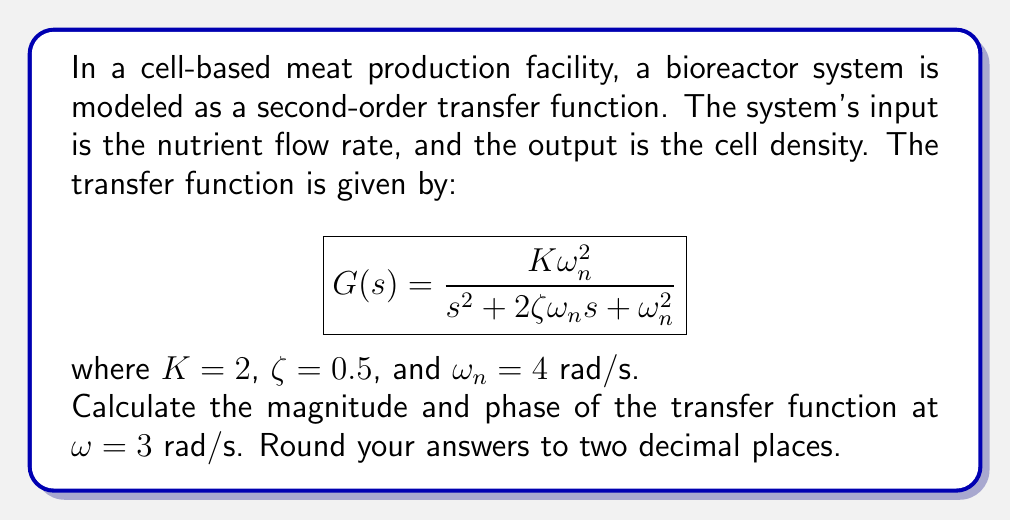Teach me how to tackle this problem. To solve this problem, we'll follow these steps:

1) First, we substitute $s = j\omega$ into the transfer function:

   $$G(j\omega) = \frac{K\omega_n^2}{(j\omega)^2 + 2\zeta\omega_n(j\omega) + \omega_n^2}$$

2) Substitute the given values:

   $$G(j\omega) = \frac{2(4^2)}{(j\omega)^2 + 2(0.5)(4)(j\omega) + 4^2}$$
   
   $$G(j\omega) = \frac{32}{(j\omega)^2 + 4j\omega + 16}$$

3) Evaluate at $\omega = 3$:

   $$G(j3) = \frac{32}{(j3)^2 + 4j3 + 16}$$
   
   $$G(j3) = \frac{32}{-9 + 12j + 16}$$
   
   $$G(j3) = \frac{32}{7 + 12j}$$

4) To find the magnitude and phase, we need to convert this to polar form. First, multiply numerator and denominator by the complex conjugate of the denominator:

   $$G(j3) = \frac{32(7 - 12j)}{(7 + 12j)(7 - 12j)} = \frac{224 - 384j}{7^2 + 12^2} = \frac{224 - 384j}{193}$$

5) Now we can calculate the magnitude:

   $$|G(j3)| = \sqrt{\left(\frac{224}{193}\right)^2 + \left(\frac{-384}{193}\right)^2} = \sqrt{\frac{50176 + 147456}{37249}} = \sqrt{\frac{197632}{37249}} \approx 2.30$$

6) And the phase:

   $$\angle G(j3) = \tan^{-1}\left(\frac{-384}{224}\right) = -1.0432 \text{ radians} \approx -59.74 \text{ degrees}$$
Answer: $|G(j3)| \approx 2.30$, $\angle G(j3) \approx -59.74°$ 